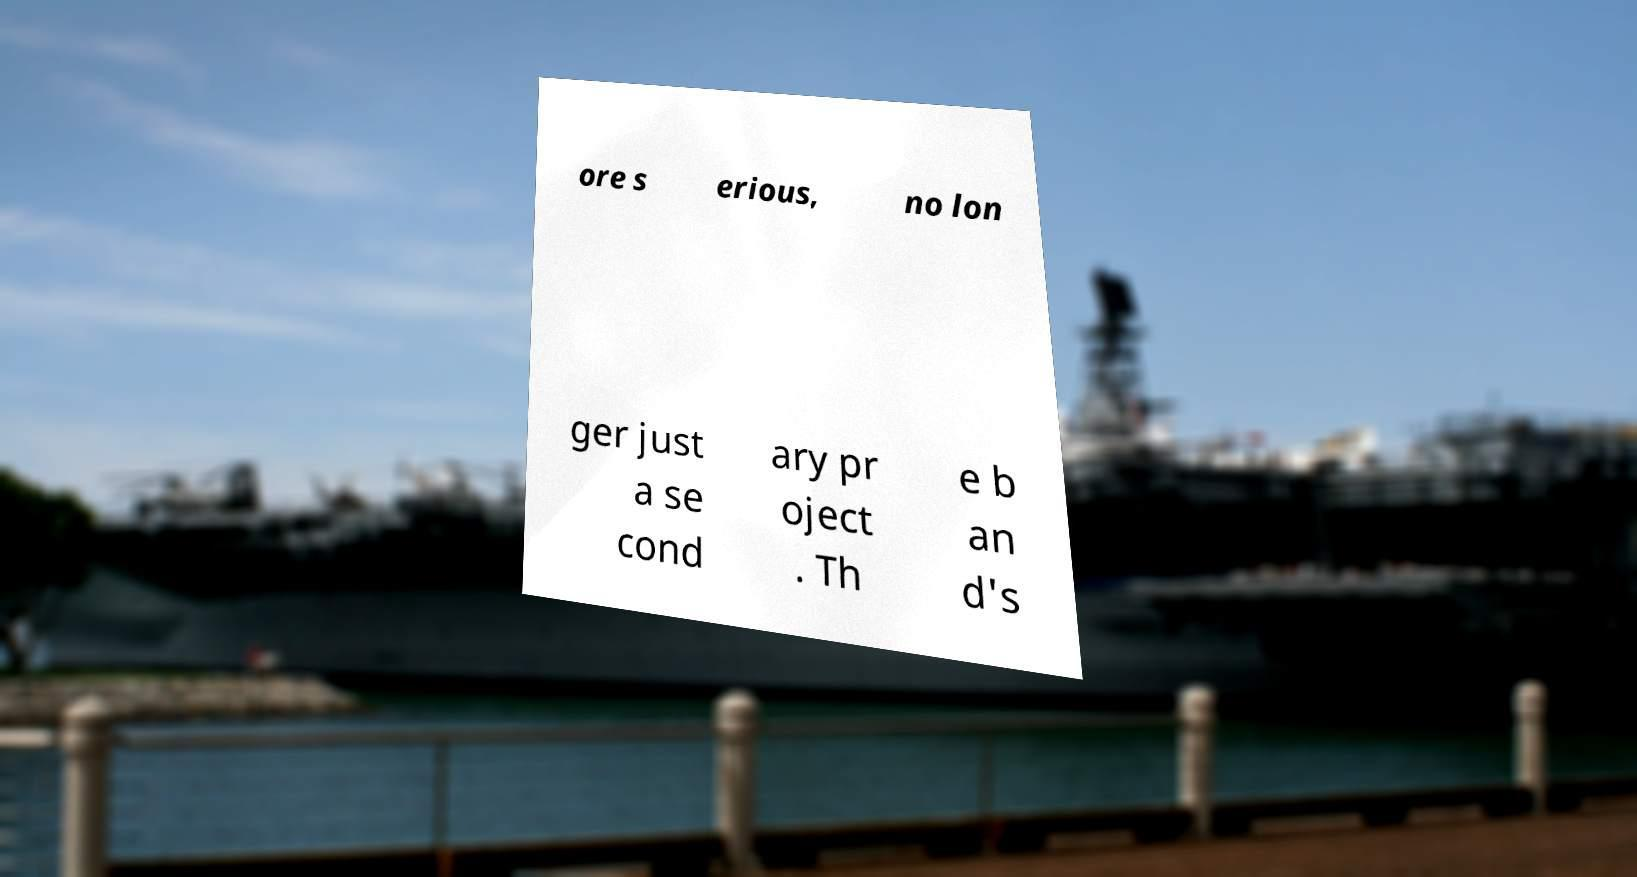Can you accurately transcribe the text from the provided image for me? ore s erious, no lon ger just a se cond ary pr oject . Th e b an d's 